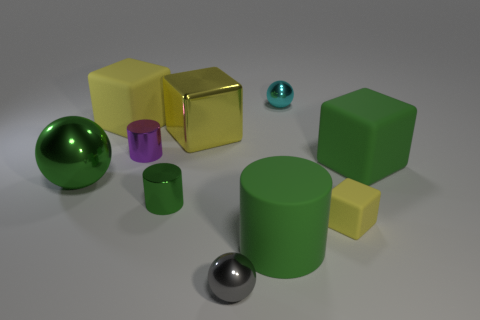There is another cylinder that is the same color as the matte cylinder; what is its size?
Give a very brief answer. Small. What number of small gray metal objects are on the left side of the large rubber object left of the large green rubber cylinder?
Keep it short and to the point. 0. Is the shape of the yellow thing that is on the right side of the gray shiny thing the same as the big rubber thing that is behind the yellow shiny block?
Make the answer very short. Yes. How many cubes are to the left of the cyan thing?
Give a very brief answer. 2. Is the big cube to the left of the large yellow shiny block made of the same material as the big green block?
Offer a terse response. Yes. What is the color of the large object that is the same shape as the small purple metal thing?
Provide a short and direct response. Green. What shape is the gray metallic object?
Make the answer very short. Sphere. How many objects are small yellow things or big gray cylinders?
Your answer should be very brief. 1. There is a big cube that is right of the cyan metallic sphere; is it the same color as the shiny thing left of the big yellow matte object?
Provide a short and direct response. Yes. What number of other things are the same shape as the tiny purple metallic thing?
Offer a very short reply. 2. 